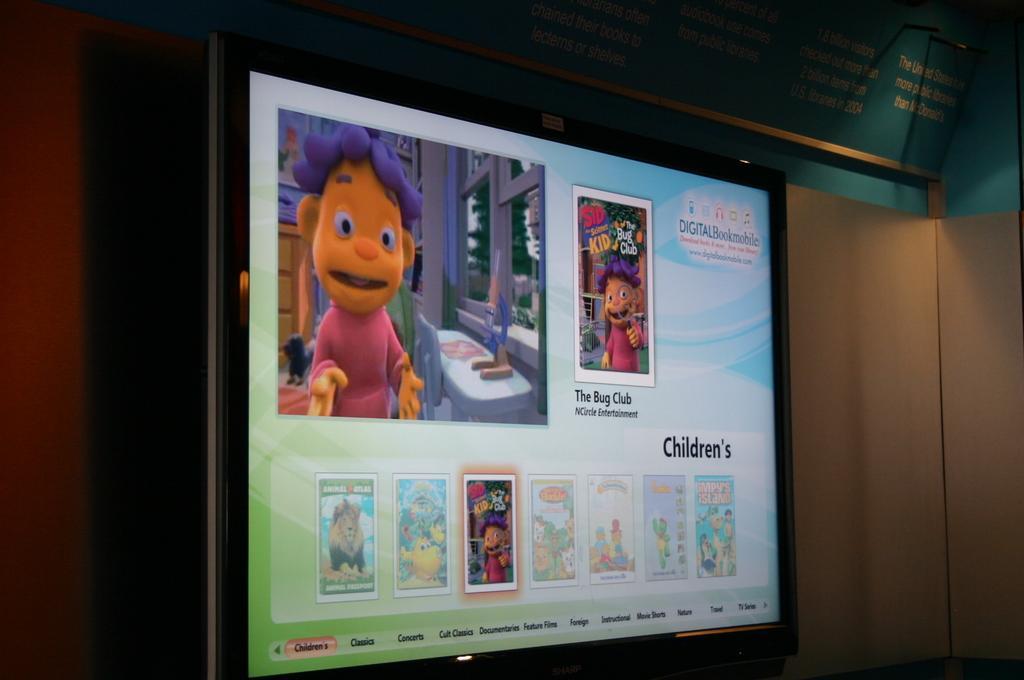Could you give a brief overview of what you see in this image? In the middle of the image, there is a screen having cartoon images and texts. In the background, there is a wall. 